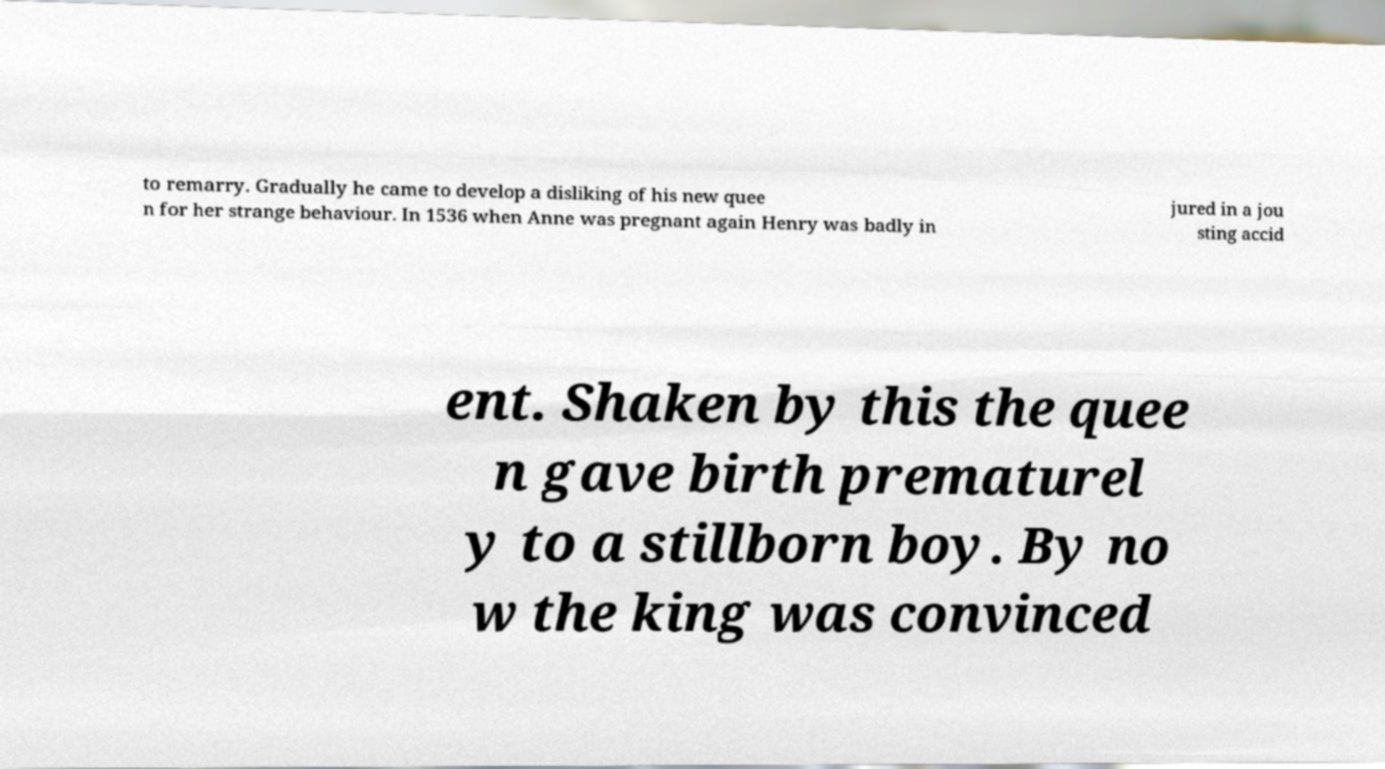Could you assist in decoding the text presented in this image and type it out clearly? to remarry. Gradually he came to develop a disliking of his new quee n for her strange behaviour. In 1536 when Anne was pregnant again Henry was badly in jured in a jou sting accid ent. Shaken by this the quee n gave birth prematurel y to a stillborn boy. By no w the king was convinced 